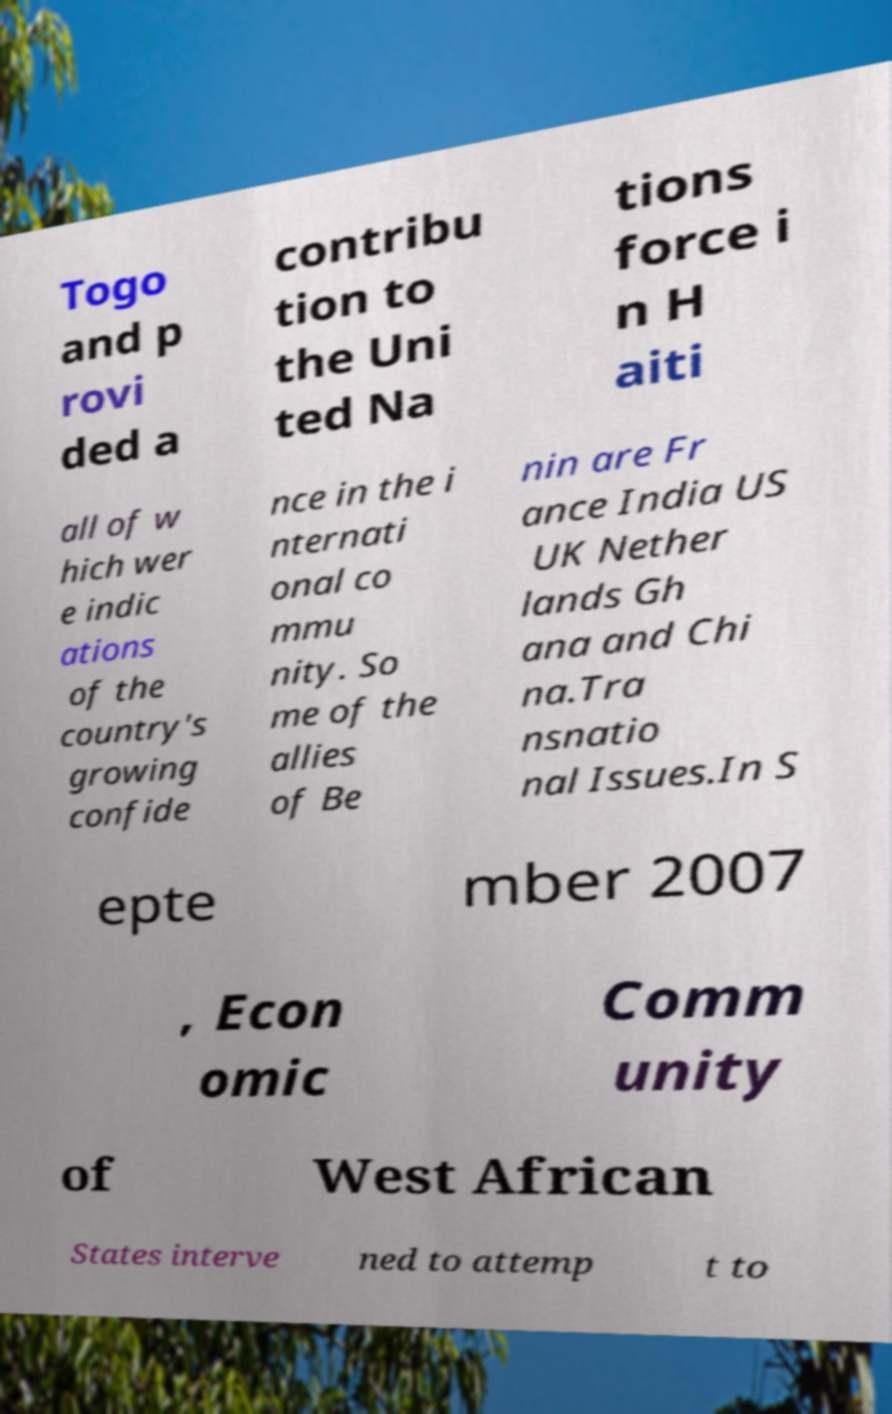Please read and relay the text visible in this image. What does it say? Togo and p rovi ded a contribu tion to the Uni ted Na tions force i n H aiti all of w hich wer e indic ations of the country's growing confide nce in the i nternati onal co mmu nity. So me of the allies of Be nin are Fr ance India US UK Nether lands Gh ana and Chi na.Tra nsnatio nal Issues.In S epte mber 2007 , Econ omic Comm unity of West African States interve ned to attemp t to 